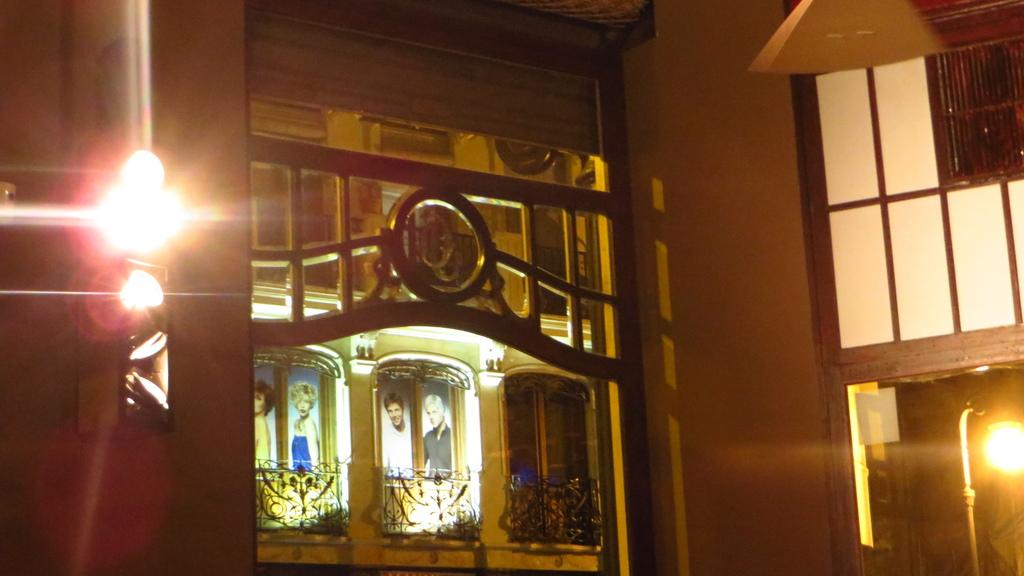What type of structure is visible in the image? There is a building in the image. What can be seen near the building? There are grills and posters visible in the image. Are there any lighting features around the building? Yes, there are lights around the building in the image. What type of seat is visible in the image? There is no seat present in the image. What type of coal is used in the grills in the image? There is no information about the type of coal used in the grills, and coal is not mentioned in the facts provided. 